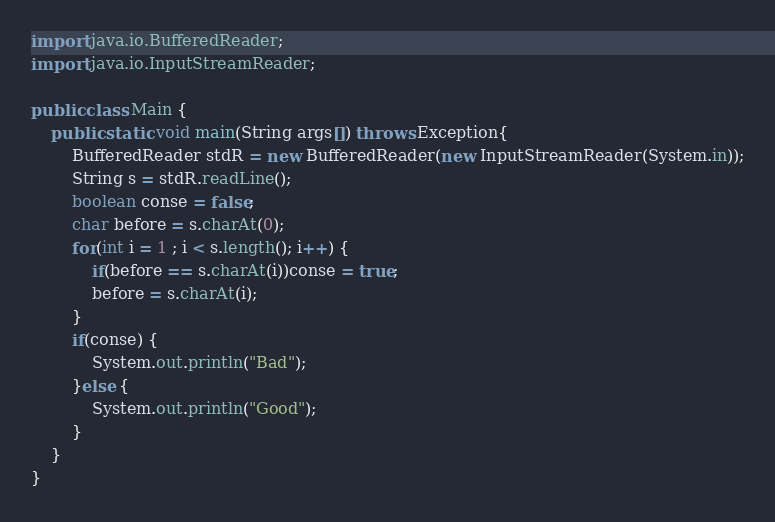<code> <loc_0><loc_0><loc_500><loc_500><_Java_>import java.io.BufferedReader;
import java.io.InputStreamReader;

public class Main {
    public static void main(String args[]) throws Exception{
        BufferedReader stdR = new BufferedReader(new InputStreamReader(System.in));
        String s = stdR.readLine();
        boolean conse = false;
        char before = s.charAt(0);
        for(int i = 1 ; i < s.length(); i++) {
            if(before == s.charAt(i))conse = true;
            before = s.charAt(i);
        }
        if(conse) {
            System.out.println("Bad");
        }else {
            System.out.println("Good");
        }
    }
}
</code> 